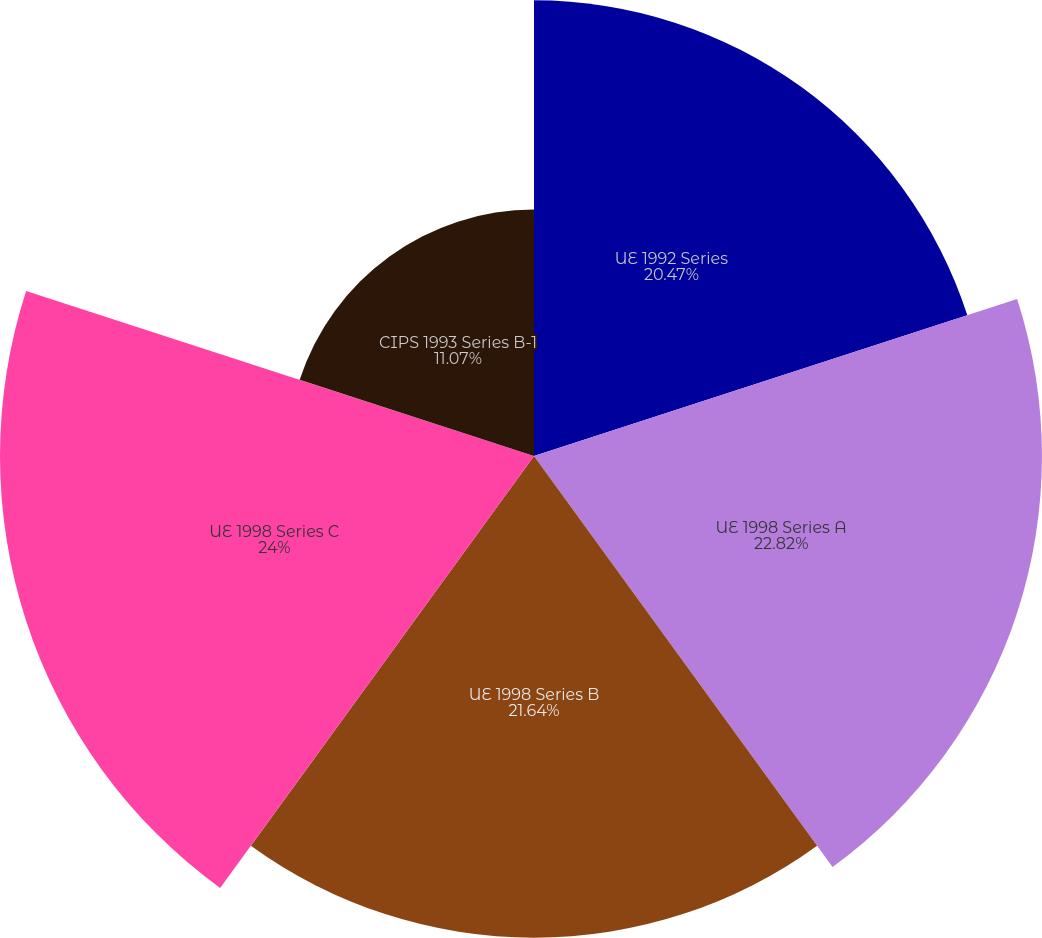<chart> <loc_0><loc_0><loc_500><loc_500><pie_chart><fcel>UE 1992 Series<fcel>UE 1998 Series A<fcel>UE 1998 Series B<fcel>UE 1998 Series C<fcel>CIPS 1993 Series B-1<nl><fcel>20.47%<fcel>22.82%<fcel>21.64%<fcel>23.99%<fcel>11.07%<nl></chart> 